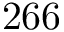<formula> <loc_0><loc_0><loc_500><loc_500>2 6 6</formula> 